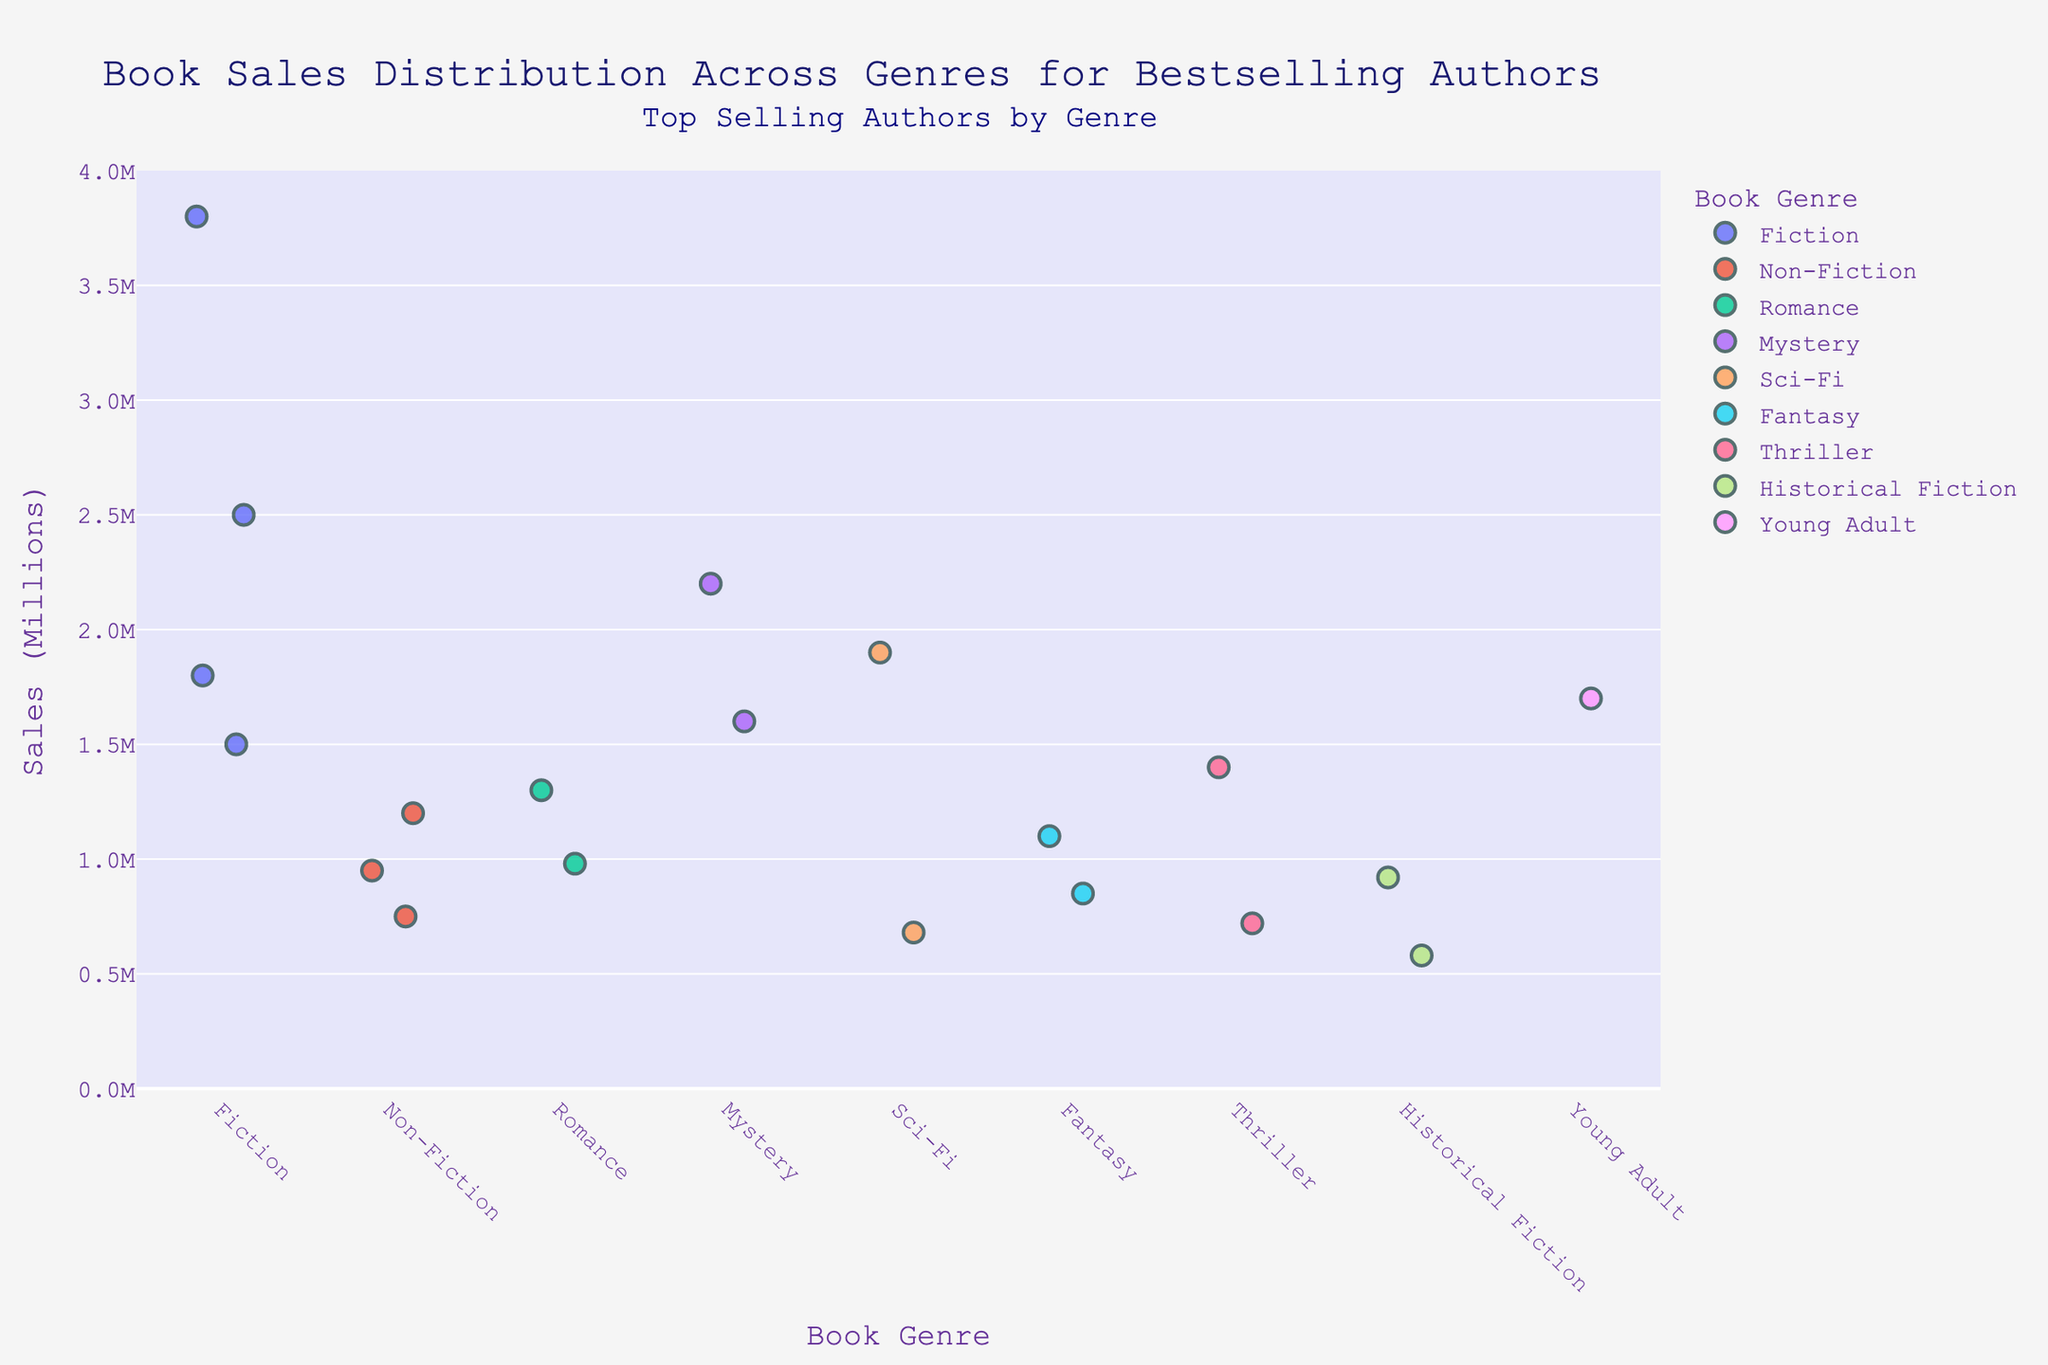What is the title of the strip plot? The title of a plot is usually displayed at the top, providing the main description of the visualization.
Answer: Book Sales Distribution Across Genres for Bestselling Authors Which genre has the highest book sales for an author, and who is the author? Identify the tallest point on the plot and look at its genre and author in the hover data label.
Answer: Fiction, J.K. Rowling How many genres are represented in the plot? Count the distinct genre labels shown on the x-axis.
Answer: 8 What is the range of sales for Fiction authors? Find the lowest and highest sales values for the Fiction genre by observing the vertical spread of Fiction points on the y-axis.
Answer: 1.5M to 3.8M Compare the sales of the top authors in Mystery and Sci-Fi genres. Which one has higher sales? Look at the highest points for Mystery and Sci-Fi genres, then compare their y-axis values.
Answer: Mystery Identify the author with the lowest sales in the Romance genre. Locate the lowest point in the Romance genre and refer to its hover data label for the author's name.
Answer: Nicholas Sparks Which genre has the most widely spread sales distribution? Observe which genre has the largest range of vertical spread on the y-axis.
Answer: Fiction Determine the average sales for Non-Fiction authors. Identify the sales for each Non-Fiction author, sum them up, and divide by the number of authors in that genre (950,000 + 750,000 + 1,200,000) / 3.
Answer: 966,667 Are there any genres where all authors have similar sales? Look for genres where the vertical spread of points is minimal, indicating close sales values.
Answer: Historical Fiction 